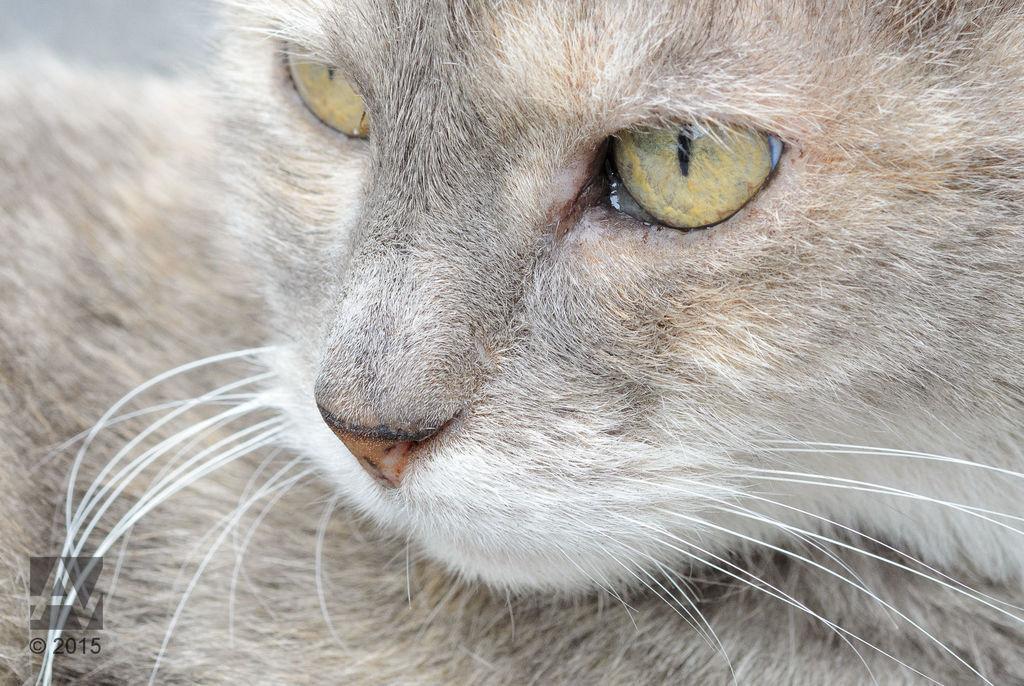Can you describe this image briefly? In this picture I can see there is a cat sitting and it is in grey color and it is looking at left side. 